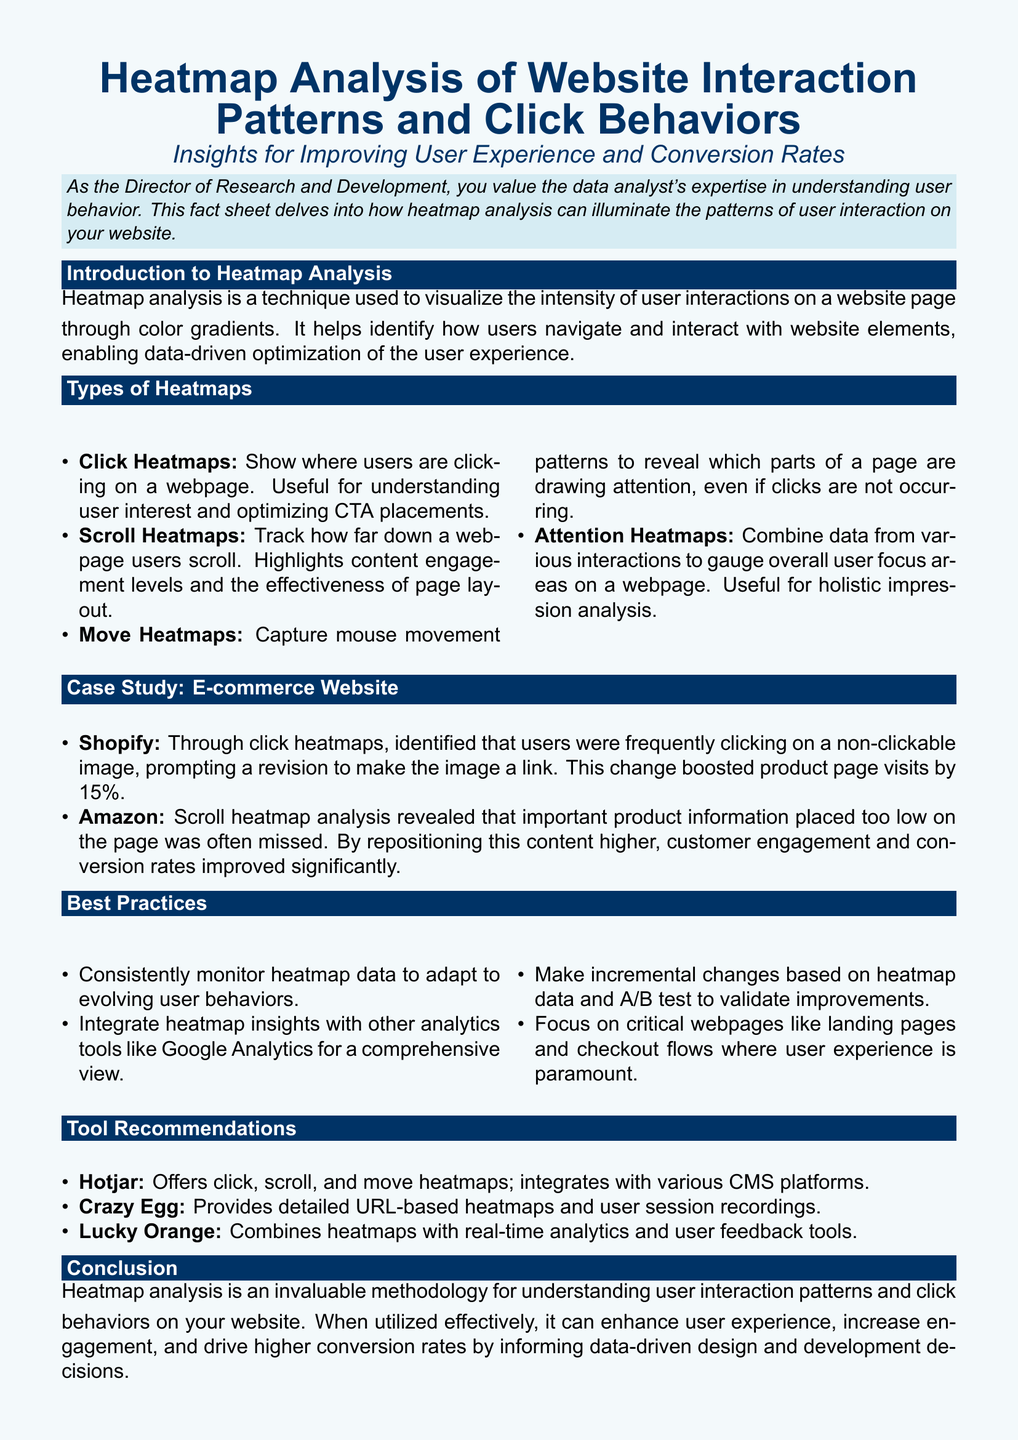What is a click heatmap? A click heatmap shows where users are clicking on a webpage and is useful for understanding user interest and optimizing CTA placements.
Answer: A click heatmap shows where users are clicking on a webpage What percentage of increased product page visits did Shopify experience after revising a non-clickable image? Shopify boosted product page visits by 15% after making a non-clickable image a link.
Answer: 15% What type of heatmap tracks how far down a webpage users scroll? The type of heatmap that tracks how far down a webpage users scroll is a scroll heatmap.
Answer: Scroll heatmap Which tool offers click, scroll, and move heatmaps? Hotjar offers click, scroll, and move heatmaps and integrates with various CMS platforms.
Answer: Hotjar What are two best practices for monitoring heatmap data? Best practices include consistently monitoring heatmap data and integrating heatmap insights with other analytics tools.
Answer: Consistently monitor data; integrate with other tools What is the primary purpose of heatmap analysis? The primary purpose of heatmap analysis is to visualize the intensity of user interactions on a website page through color gradients.
Answer: To visualize the intensity of user interactions What type of heatmap captures mouse movement patterns? The type of heatmap that captures mouse movement patterns is a move heatmap.
Answer: Move heatmap What e-commerce website repositioned product information to improve customer engagement? Amazon repositioned important product information to improve customer engagement and conversion rates.
Answer: Amazon 